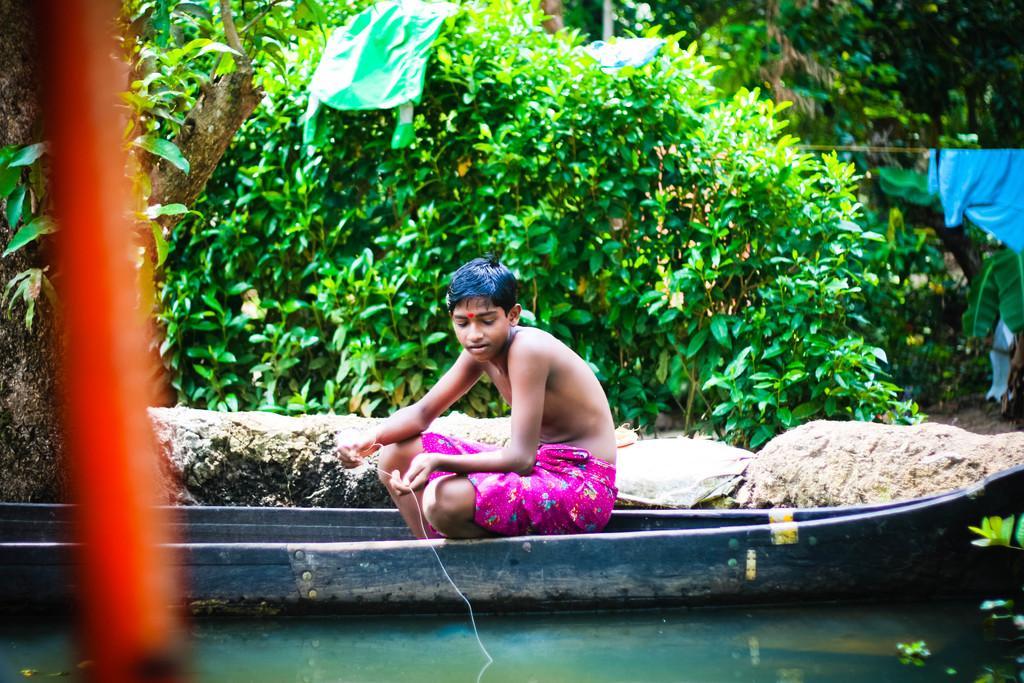Can you describe this image briefly? In this picture we can see a boy is sitting on a boat and the boat is on the water. Behind the boy there are rocks, trees and clothes. 